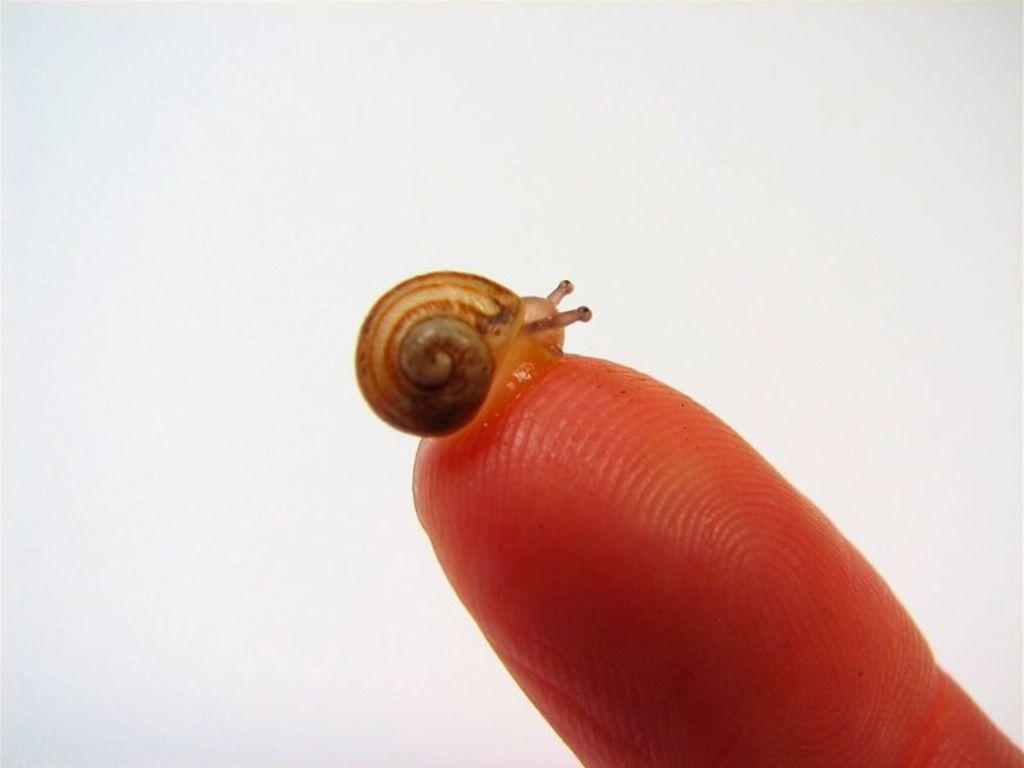What type of animal is in the image? There is a snail in the image. Where is the snail located in the image? The snail is on the finger of a person. What type of chair is the snail sitting on in the image? There is no chair present in the image; the snail is on the finger of a person. How does the snail perform tricks on a skateboard in the image? There is no skateboard present in the image, and snails do not have the ability to perform tricks. 